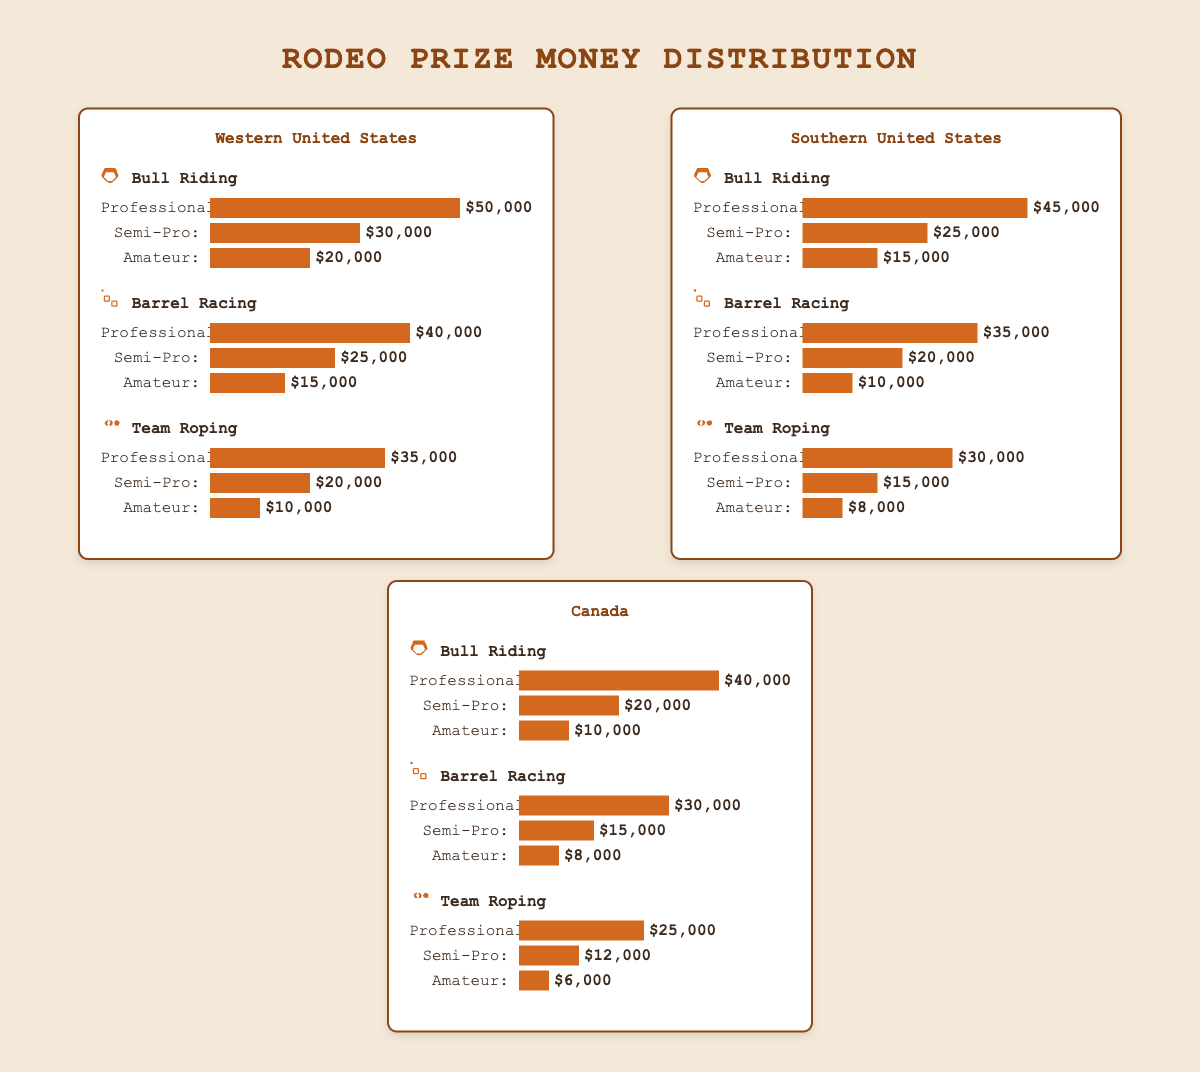Which region offers the highest prize money for Professional Bull Riding? To determine the highest prize money for Professional Bull Riding, compare the values for Professional Bull Riding across the Western United States ($50,000), Southern United States ($45,000), and Canada ($40,000). The Western United States offers the highest at $50,000.
Answer: Western United States What is the total prize money for Semi-Pro events in the Southern United States? Add the prize money for Semi-Pro categories in all events in the Southern United States: Bull Riding ($25,000) + Barrel Racing ($20,000) + Team Roping ($15,000). The total is $25,000 + $20,000 + $15,000 = $60,000.
Answer: $60,000 Which event in Canada has the least prize money for Amateurs? Compare the prize money amounts for Amateurs in Canada across all events: Bull Riding ($10,000), Barrel Racing ($8,000), and Team Roping ($6,000). Team Roping offers the least prize money at $6,000.
Answer: Team Roping Is the prize money distribution for Professional Barrel Racing higher in the Western United States or Canada? Compare the values for Professional Barrel Racing in the Western United States ($40,000) and Canada ($30,000). The Western United States has a higher prize money distribution for this event.
Answer: Western United States What is the combined prize money for Professional Team Roping across all regions? Add the prize money for Professional Team Roping in each region: Western United States ($35,000), Southern United States ($30,000), and Canada ($25,000). The combined prize money is $35,000 + $30,000 + $25,000 = $90,000.
Answer: $90,000 How does the prize distribution for Barrel Racing compare between Professional and Amateur categories in the Western United States? For Barrel Racing in the Western United States, the prize money for Professionals is $40,000 and for Amateurs is $15,000. The Professional prize money is significantly higher than the Amateur prize money.
Answer: Professional prize money is higher If you average the prize money for Professional Bull Riding across all regions, what is the result? Sum the prize money for Professional Bull Riding in all regions: Western United States ($50,000), Southern United States ($45,000), and Canada ($40,000). The total is $50,000 + $45,000 + $40,000 = $135,000. Divide this by the number of regions (3): $135,000 / 3 = $45,000.
Answer: $45,000 